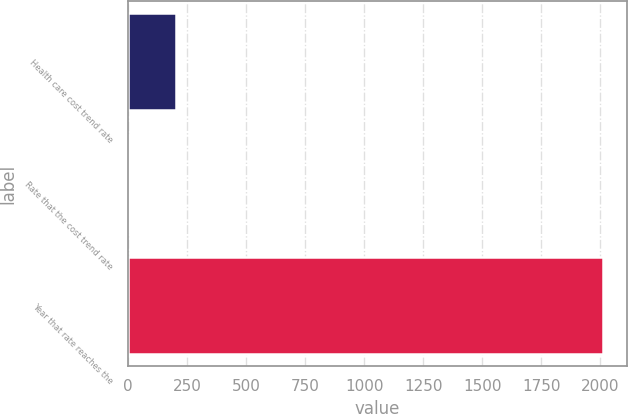Convert chart. <chart><loc_0><loc_0><loc_500><loc_500><bar_chart><fcel>Health care cost trend rate<fcel>Rate that the cost trend rate<fcel>Year that rate reaches the<nl><fcel>205.7<fcel>5<fcel>2012<nl></chart> 